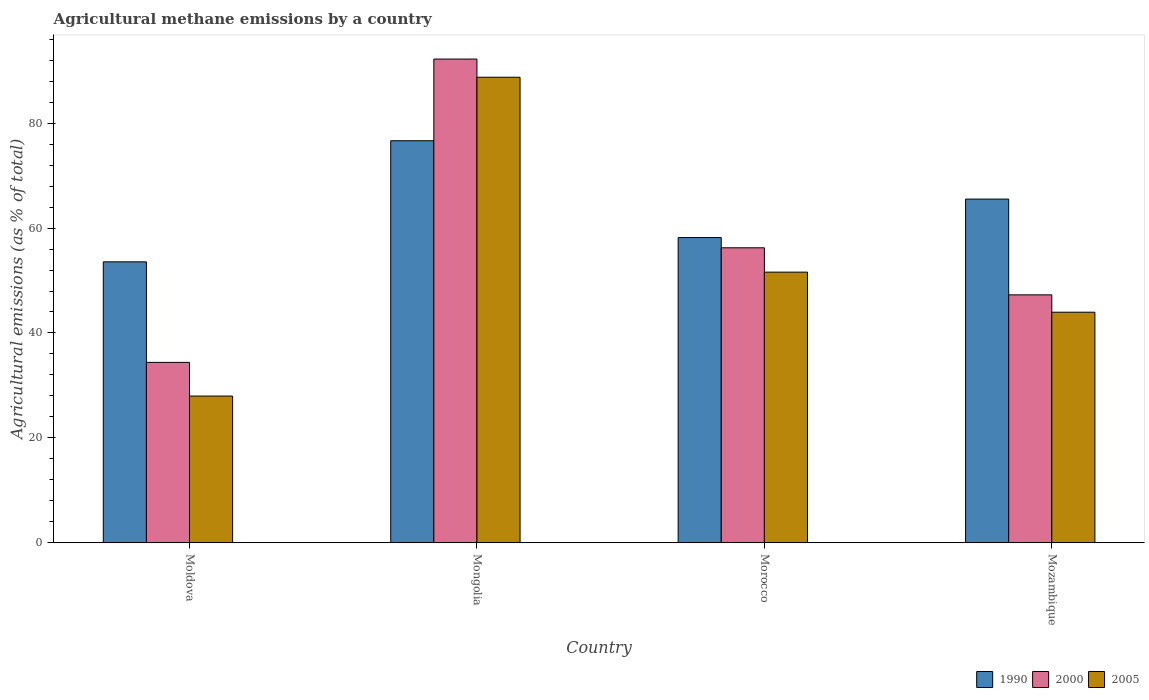How many different coloured bars are there?
Keep it short and to the point. 3. How many groups of bars are there?
Keep it short and to the point. 4. Are the number of bars per tick equal to the number of legend labels?
Offer a terse response. Yes. Are the number of bars on each tick of the X-axis equal?
Your response must be concise. Yes. How many bars are there on the 1st tick from the left?
Offer a very short reply. 3. What is the label of the 3rd group of bars from the left?
Your answer should be very brief. Morocco. In how many cases, is the number of bars for a given country not equal to the number of legend labels?
Your answer should be compact. 0. What is the amount of agricultural methane emitted in 1990 in Moldova?
Give a very brief answer. 53.56. Across all countries, what is the maximum amount of agricultural methane emitted in 2005?
Your answer should be very brief. 88.77. Across all countries, what is the minimum amount of agricultural methane emitted in 1990?
Ensure brevity in your answer.  53.56. In which country was the amount of agricultural methane emitted in 1990 maximum?
Make the answer very short. Mongolia. In which country was the amount of agricultural methane emitted in 2005 minimum?
Make the answer very short. Moldova. What is the total amount of agricultural methane emitted in 1990 in the graph?
Give a very brief answer. 253.95. What is the difference between the amount of agricultural methane emitted in 2005 in Moldova and that in Morocco?
Give a very brief answer. -23.63. What is the difference between the amount of agricultural methane emitted in 2000 in Mongolia and the amount of agricultural methane emitted in 1990 in Mozambique?
Give a very brief answer. 26.71. What is the average amount of agricultural methane emitted in 2005 per country?
Give a very brief answer. 53.07. What is the difference between the amount of agricultural methane emitted of/in 1990 and amount of agricultural methane emitted of/in 2005 in Mozambique?
Offer a very short reply. 21.57. What is the ratio of the amount of agricultural methane emitted in 2005 in Moldova to that in Mongolia?
Make the answer very short. 0.32. What is the difference between the highest and the second highest amount of agricultural methane emitted in 2005?
Ensure brevity in your answer.  44.81. What is the difference between the highest and the lowest amount of agricultural methane emitted in 1990?
Ensure brevity in your answer.  23.1. What does the 2nd bar from the left in Mongolia represents?
Your answer should be very brief. 2000. What does the 2nd bar from the right in Moldova represents?
Keep it short and to the point. 2000. Is it the case that in every country, the sum of the amount of agricultural methane emitted in 2005 and amount of agricultural methane emitted in 2000 is greater than the amount of agricultural methane emitted in 1990?
Keep it short and to the point. Yes. How many bars are there?
Provide a succinct answer. 12. Are all the bars in the graph horizontal?
Your answer should be very brief. No. What is the difference between two consecutive major ticks on the Y-axis?
Your response must be concise. 20. Are the values on the major ticks of Y-axis written in scientific E-notation?
Your response must be concise. No. Does the graph contain any zero values?
Your response must be concise. No. Where does the legend appear in the graph?
Give a very brief answer. Bottom right. How many legend labels are there?
Your answer should be very brief. 3. How are the legend labels stacked?
Keep it short and to the point. Horizontal. What is the title of the graph?
Offer a terse response. Agricultural methane emissions by a country. What is the label or title of the X-axis?
Offer a very short reply. Country. What is the label or title of the Y-axis?
Provide a short and direct response. Agricultural emissions (as % of total). What is the Agricultural emissions (as % of total) in 1990 in Moldova?
Your response must be concise. 53.56. What is the Agricultural emissions (as % of total) in 2000 in Moldova?
Give a very brief answer. 34.39. What is the Agricultural emissions (as % of total) of 2005 in Moldova?
Ensure brevity in your answer.  27.97. What is the Agricultural emissions (as % of total) of 1990 in Mongolia?
Your response must be concise. 76.66. What is the Agricultural emissions (as % of total) of 2000 in Mongolia?
Make the answer very short. 92.24. What is the Agricultural emissions (as % of total) of 2005 in Mongolia?
Your answer should be very brief. 88.77. What is the Agricultural emissions (as % of total) of 1990 in Morocco?
Give a very brief answer. 58.2. What is the Agricultural emissions (as % of total) in 2000 in Morocco?
Your answer should be very brief. 56.24. What is the Agricultural emissions (as % of total) in 2005 in Morocco?
Your answer should be compact. 51.6. What is the Agricultural emissions (as % of total) in 1990 in Mozambique?
Offer a terse response. 65.53. What is the Agricultural emissions (as % of total) in 2000 in Mozambique?
Offer a very short reply. 47.27. What is the Agricultural emissions (as % of total) in 2005 in Mozambique?
Offer a terse response. 43.96. Across all countries, what is the maximum Agricultural emissions (as % of total) of 1990?
Make the answer very short. 76.66. Across all countries, what is the maximum Agricultural emissions (as % of total) of 2000?
Offer a very short reply. 92.24. Across all countries, what is the maximum Agricultural emissions (as % of total) of 2005?
Provide a succinct answer. 88.77. Across all countries, what is the minimum Agricultural emissions (as % of total) in 1990?
Ensure brevity in your answer.  53.56. Across all countries, what is the minimum Agricultural emissions (as % of total) in 2000?
Provide a succinct answer. 34.39. Across all countries, what is the minimum Agricultural emissions (as % of total) of 2005?
Give a very brief answer. 27.97. What is the total Agricultural emissions (as % of total) of 1990 in the graph?
Provide a succinct answer. 253.95. What is the total Agricultural emissions (as % of total) of 2000 in the graph?
Ensure brevity in your answer.  230.14. What is the total Agricultural emissions (as % of total) of 2005 in the graph?
Your response must be concise. 212.3. What is the difference between the Agricultural emissions (as % of total) of 1990 in Moldova and that in Mongolia?
Give a very brief answer. -23.1. What is the difference between the Agricultural emissions (as % of total) in 2000 in Moldova and that in Mongolia?
Your answer should be compact. -57.85. What is the difference between the Agricultural emissions (as % of total) in 2005 in Moldova and that in Mongolia?
Offer a very short reply. -60.8. What is the difference between the Agricultural emissions (as % of total) of 1990 in Moldova and that in Morocco?
Provide a short and direct response. -4.63. What is the difference between the Agricultural emissions (as % of total) of 2000 in Moldova and that in Morocco?
Offer a very short reply. -21.85. What is the difference between the Agricultural emissions (as % of total) in 2005 in Moldova and that in Morocco?
Your answer should be very brief. -23.63. What is the difference between the Agricultural emissions (as % of total) in 1990 in Moldova and that in Mozambique?
Give a very brief answer. -11.97. What is the difference between the Agricultural emissions (as % of total) of 2000 in Moldova and that in Mozambique?
Ensure brevity in your answer.  -12.88. What is the difference between the Agricultural emissions (as % of total) of 2005 in Moldova and that in Mozambique?
Offer a terse response. -15.99. What is the difference between the Agricultural emissions (as % of total) of 1990 in Mongolia and that in Morocco?
Provide a short and direct response. 18.46. What is the difference between the Agricultural emissions (as % of total) of 2000 in Mongolia and that in Morocco?
Make the answer very short. 35.99. What is the difference between the Agricultural emissions (as % of total) in 2005 in Mongolia and that in Morocco?
Provide a short and direct response. 37.17. What is the difference between the Agricultural emissions (as % of total) in 1990 in Mongolia and that in Mozambique?
Provide a succinct answer. 11.13. What is the difference between the Agricultural emissions (as % of total) of 2000 in Mongolia and that in Mozambique?
Your response must be concise. 44.97. What is the difference between the Agricultural emissions (as % of total) of 2005 in Mongolia and that in Mozambique?
Offer a terse response. 44.81. What is the difference between the Agricultural emissions (as % of total) of 1990 in Morocco and that in Mozambique?
Provide a short and direct response. -7.34. What is the difference between the Agricultural emissions (as % of total) of 2000 in Morocco and that in Mozambique?
Your answer should be very brief. 8.98. What is the difference between the Agricultural emissions (as % of total) in 2005 in Morocco and that in Mozambique?
Keep it short and to the point. 7.65. What is the difference between the Agricultural emissions (as % of total) in 1990 in Moldova and the Agricultural emissions (as % of total) in 2000 in Mongolia?
Your response must be concise. -38.67. What is the difference between the Agricultural emissions (as % of total) in 1990 in Moldova and the Agricultural emissions (as % of total) in 2005 in Mongolia?
Provide a short and direct response. -35.21. What is the difference between the Agricultural emissions (as % of total) in 2000 in Moldova and the Agricultural emissions (as % of total) in 2005 in Mongolia?
Provide a short and direct response. -54.38. What is the difference between the Agricultural emissions (as % of total) in 1990 in Moldova and the Agricultural emissions (as % of total) in 2000 in Morocco?
Provide a succinct answer. -2.68. What is the difference between the Agricultural emissions (as % of total) in 1990 in Moldova and the Agricultural emissions (as % of total) in 2005 in Morocco?
Provide a short and direct response. 1.96. What is the difference between the Agricultural emissions (as % of total) in 2000 in Moldova and the Agricultural emissions (as % of total) in 2005 in Morocco?
Keep it short and to the point. -17.21. What is the difference between the Agricultural emissions (as % of total) of 1990 in Moldova and the Agricultural emissions (as % of total) of 2000 in Mozambique?
Your response must be concise. 6.29. What is the difference between the Agricultural emissions (as % of total) of 1990 in Moldova and the Agricultural emissions (as % of total) of 2005 in Mozambique?
Give a very brief answer. 9.61. What is the difference between the Agricultural emissions (as % of total) in 2000 in Moldova and the Agricultural emissions (as % of total) in 2005 in Mozambique?
Your answer should be compact. -9.57. What is the difference between the Agricultural emissions (as % of total) of 1990 in Mongolia and the Agricultural emissions (as % of total) of 2000 in Morocco?
Offer a very short reply. 20.42. What is the difference between the Agricultural emissions (as % of total) of 1990 in Mongolia and the Agricultural emissions (as % of total) of 2005 in Morocco?
Your answer should be very brief. 25.06. What is the difference between the Agricultural emissions (as % of total) in 2000 in Mongolia and the Agricultural emissions (as % of total) in 2005 in Morocco?
Provide a succinct answer. 40.63. What is the difference between the Agricultural emissions (as % of total) in 1990 in Mongolia and the Agricultural emissions (as % of total) in 2000 in Mozambique?
Provide a short and direct response. 29.39. What is the difference between the Agricultural emissions (as % of total) of 1990 in Mongolia and the Agricultural emissions (as % of total) of 2005 in Mozambique?
Offer a very short reply. 32.7. What is the difference between the Agricultural emissions (as % of total) in 2000 in Mongolia and the Agricultural emissions (as % of total) in 2005 in Mozambique?
Your answer should be compact. 48.28. What is the difference between the Agricultural emissions (as % of total) in 1990 in Morocco and the Agricultural emissions (as % of total) in 2000 in Mozambique?
Make the answer very short. 10.93. What is the difference between the Agricultural emissions (as % of total) of 1990 in Morocco and the Agricultural emissions (as % of total) of 2005 in Mozambique?
Your response must be concise. 14.24. What is the difference between the Agricultural emissions (as % of total) in 2000 in Morocco and the Agricultural emissions (as % of total) in 2005 in Mozambique?
Offer a terse response. 12.29. What is the average Agricultural emissions (as % of total) of 1990 per country?
Provide a short and direct response. 63.49. What is the average Agricultural emissions (as % of total) in 2000 per country?
Provide a short and direct response. 57.54. What is the average Agricultural emissions (as % of total) in 2005 per country?
Keep it short and to the point. 53.07. What is the difference between the Agricultural emissions (as % of total) of 1990 and Agricultural emissions (as % of total) of 2000 in Moldova?
Your answer should be compact. 19.17. What is the difference between the Agricultural emissions (as % of total) of 1990 and Agricultural emissions (as % of total) of 2005 in Moldova?
Your answer should be compact. 25.59. What is the difference between the Agricultural emissions (as % of total) in 2000 and Agricultural emissions (as % of total) in 2005 in Moldova?
Offer a terse response. 6.42. What is the difference between the Agricultural emissions (as % of total) in 1990 and Agricultural emissions (as % of total) in 2000 in Mongolia?
Your answer should be compact. -15.58. What is the difference between the Agricultural emissions (as % of total) in 1990 and Agricultural emissions (as % of total) in 2005 in Mongolia?
Keep it short and to the point. -12.11. What is the difference between the Agricultural emissions (as % of total) in 2000 and Agricultural emissions (as % of total) in 2005 in Mongolia?
Make the answer very short. 3.47. What is the difference between the Agricultural emissions (as % of total) of 1990 and Agricultural emissions (as % of total) of 2000 in Morocco?
Offer a terse response. 1.95. What is the difference between the Agricultural emissions (as % of total) in 1990 and Agricultural emissions (as % of total) in 2005 in Morocco?
Provide a succinct answer. 6.59. What is the difference between the Agricultural emissions (as % of total) in 2000 and Agricultural emissions (as % of total) in 2005 in Morocco?
Make the answer very short. 4.64. What is the difference between the Agricultural emissions (as % of total) of 1990 and Agricultural emissions (as % of total) of 2000 in Mozambique?
Provide a short and direct response. 18.26. What is the difference between the Agricultural emissions (as % of total) in 1990 and Agricultural emissions (as % of total) in 2005 in Mozambique?
Your answer should be very brief. 21.57. What is the difference between the Agricultural emissions (as % of total) of 2000 and Agricultural emissions (as % of total) of 2005 in Mozambique?
Ensure brevity in your answer.  3.31. What is the ratio of the Agricultural emissions (as % of total) in 1990 in Moldova to that in Mongolia?
Your response must be concise. 0.7. What is the ratio of the Agricultural emissions (as % of total) in 2000 in Moldova to that in Mongolia?
Offer a very short reply. 0.37. What is the ratio of the Agricultural emissions (as % of total) of 2005 in Moldova to that in Mongolia?
Offer a terse response. 0.32. What is the ratio of the Agricultural emissions (as % of total) of 1990 in Moldova to that in Morocco?
Offer a very short reply. 0.92. What is the ratio of the Agricultural emissions (as % of total) in 2000 in Moldova to that in Morocco?
Give a very brief answer. 0.61. What is the ratio of the Agricultural emissions (as % of total) of 2005 in Moldova to that in Morocco?
Offer a terse response. 0.54. What is the ratio of the Agricultural emissions (as % of total) in 1990 in Moldova to that in Mozambique?
Give a very brief answer. 0.82. What is the ratio of the Agricultural emissions (as % of total) of 2000 in Moldova to that in Mozambique?
Provide a short and direct response. 0.73. What is the ratio of the Agricultural emissions (as % of total) in 2005 in Moldova to that in Mozambique?
Provide a succinct answer. 0.64. What is the ratio of the Agricultural emissions (as % of total) in 1990 in Mongolia to that in Morocco?
Give a very brief answer. 1.32. What is the ratio of the Agricultural emissions (as % of total) of 2000 in Mongolia to that in Morocco?
Your answer should be compact. 1.64. What is the ratio of the Agricultural emissions (as % of total) in 2005 in Mongolia to that in Morocco?
Provide a short and direct response. 1.72. What is the ratio of the Agricultural emissions (as % of total) in 1990 in Mongolia to that in Mozambique?
Your response must be concise. 1.17. What is the ratio of the Agricultural emissions (as % of total) in 2000 in Mongolia to that in Mozambique?
Offer a terse response. 1.95. What is the ratio of the Agricultural emissions (as % of total) of 2005 in Mongolia to that in Mozambique?
Your answer should be compact. 2.02. What is the ratio of the Agricultural emissions (as % of total) of 1990 in Morocco to that in Mozambique?
Make the answer very short. 0.89. What is the ratio of the Agricultural emissions (as % of total) of 2000 in Morocco to that in Mozambique?
Your answer should be very brief. 1.19. What is the ratio of the Agricultural emissions (as % of total) of 2005 in Morocco to that in Mozambique?
Keep it short and to the point. 1.17. What is the difference between the highest and the second highest Agricultural emissions (as % of total) in 1990?
Ensure brevity in your answer.  11.13. What is the difference between the highest and the second highest Agricultural emissions (as % of total) of 2000?
Ensure brevity in your answer.  35.99. What is the difference between the highest and the second highest Agricultural emissions (as % of total) in 2005?
Give a very brief answer. 37.17. What is the difference between the highest and the lowest Agricultural emissions (as % of total) of 1990?
Your answer should be compact. 23.1. What is the difference between the highest and the lowest Agricultural emissions (as % of total) in 2000?
Ensure brevity in your answer.  57.85. What is the difference between the highest and the lowest Agricultural emissions (as % of total) of 2005?
Ensure brevity in your answer.  60.8. 